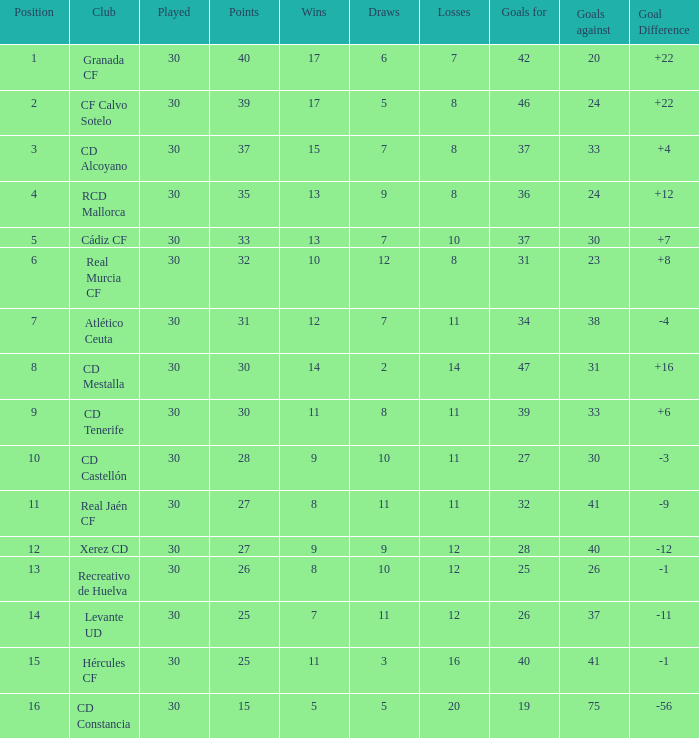How many times has a team won with under 30 goals against, above 25 goals for, and more than 5 draws? 3.0. 